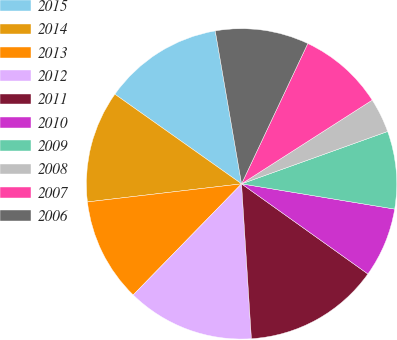Convert chart. <chart><loc_0><loc_0><loc_500><loc_500><pie_chart><fcel>2015<fcel>2014<fcel>2013<fcel>2012<fcel>2011<fcel>2010<fcel>2009<fcel>2008<fcel>2007<fcel>2006<nl><fcel>12.49%<fcel>11.66%<fcel>10.84%<fcel>13.31%<fcel>14.13%<fcel>7.26%<fcel>8.08%<fcel>3.59%<fcel>8.91%<fcel>9.73%<nl></chart> 